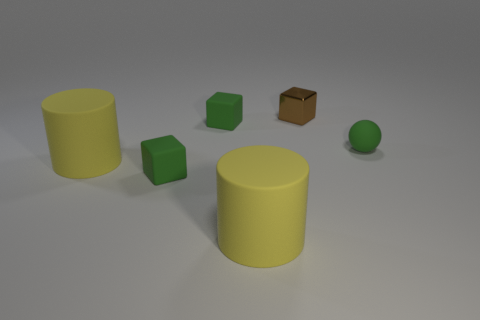Add 3 large rubber cylinders. How many objects exist? 9 Subtract all spheres. How many objects are left? 5 Subtract 0 yellow blocks. How many objects are left? 6 Subtract all tiny green objects. Subtract all green shiny objects. How many objects are left? 3 Add 3 green objects. How many green objects are left? 6 Add 6 small green balls. How many small green balls exist? 7 